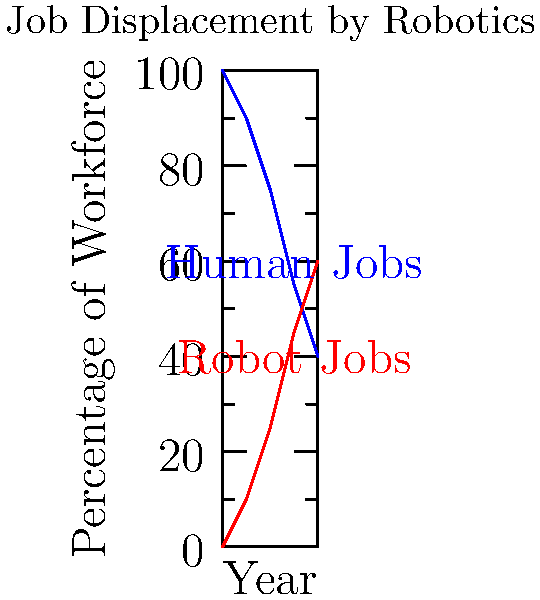Based on the vector chart showing the projected impact of robotics on job displacement, in which year does the percentage of jobs performed by robots surpass that of human jobs? To determine the year when robot jobs surpass human jobs, we need to analyze the data points for each year:

1. 2020: Human jobs 100%, Robot jobs 0%
2. 2025: Human jobs 90%, Robot jobs 10%
3. 2030: Human jobs 75%, Robot jobs 25%
4. 2035: Human jobs 55%, Robot jobs 45%
5. 2040: Human jobs 40%, Robot jobs 60%

We can see that the crossover point occurs between 2035 and 2040. To find the exact year, we need to calculate the rate of change and use linear interpolation:

Human job decrease rate: $(55% - 40%) / (2040 - 2035) = 3%$ per year
Robot job increase rate: $(60% - 45%) / (2040 - 2035) = 3%$ per year

Starting from 2035:
Human jobs: $55% - 3x = 50%$
Robot jobs: $45% + 3x = 50%$

Solving for $x$:
$x = (50% - 45%) / 3 = 5/3 = 1.67$ years

Therefore, the crossover point occurs $1.67$ years after 2035:

$2035 + 1.67 = 2036.67$

Rounding to the nearest year, we get 2037.
Answer: 2037 